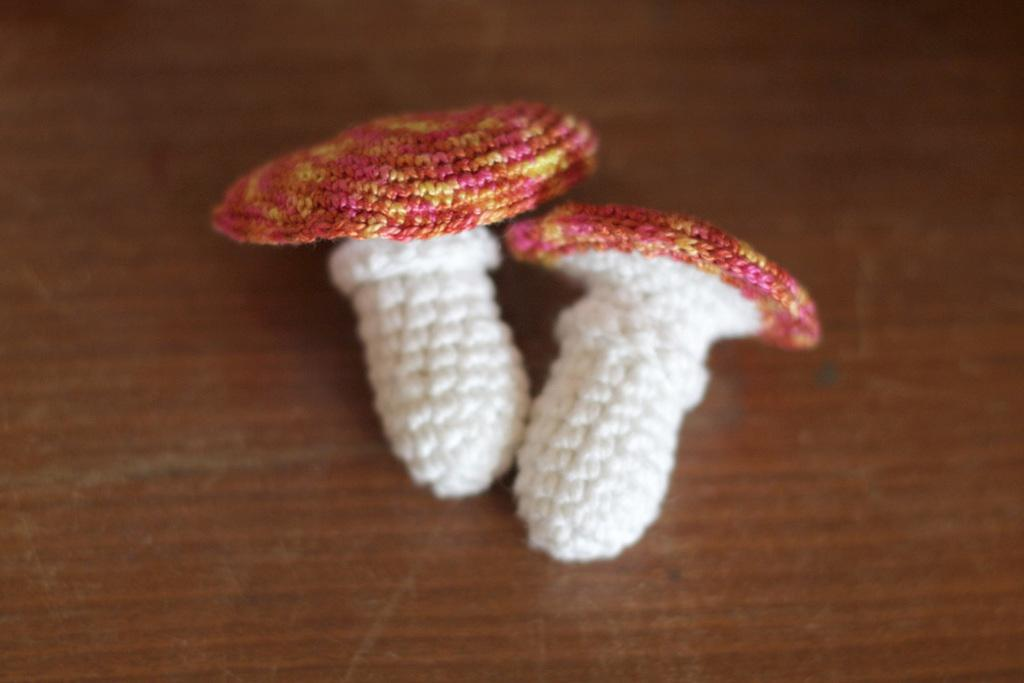How many objects can be seen in the image? There are two objects in the image. What colors are the objects? The objects are white and pink in color. What are the objects made of? The objects are made up of threads. Where are the objects placed? The objects are kept on a surface. Is there a cactus growing between the two objects in the image? No, there is no cactus present in the image. Can you see any toes in the image? No, there are no toes visible in the image. 